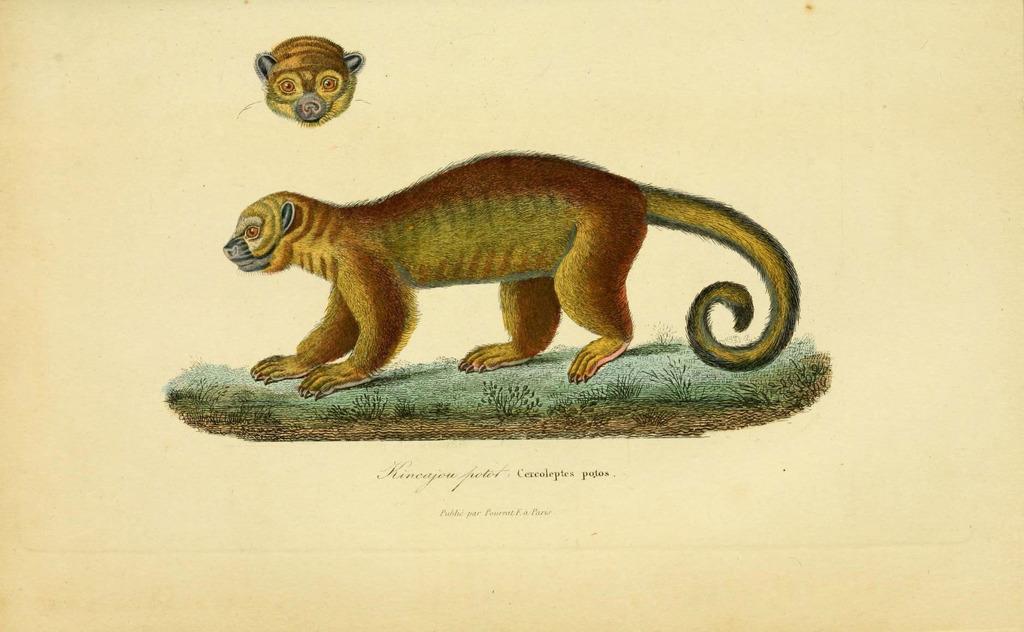Can you describe this image briefly? In the center of this picture we can see a picture of an animal standing on the green grass. At the top we can see the picture of the head of an animal. At the bottom we can see the text. 